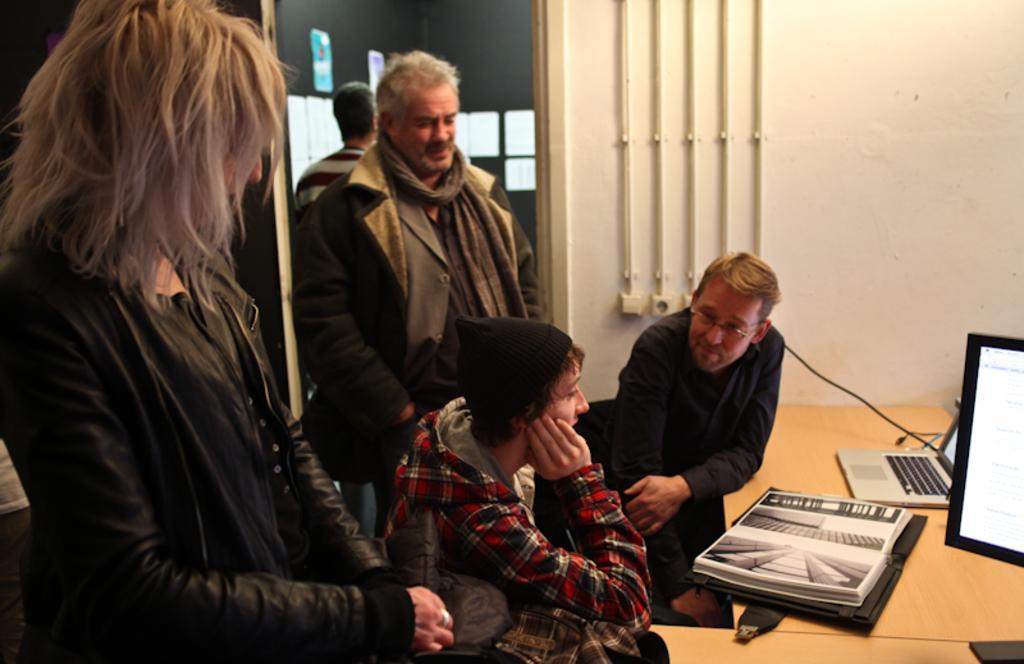In one or two sentences, can you explain what this image depicts? In this image I can see few persons standing and few persons sitting in front of the desk and on the desk I can see a monitor, a laptop and few other objects. In the background I can see the wall, few pipes and few other objects. 